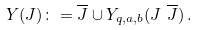Convert formula to latex. <formula><loc_0><loc_0><loc_500><loc_500>Y ( J ) \colon = \overline { J } \cup Y _ { q , a , b } ( J \ \overline { J } ) \, .</formula> 